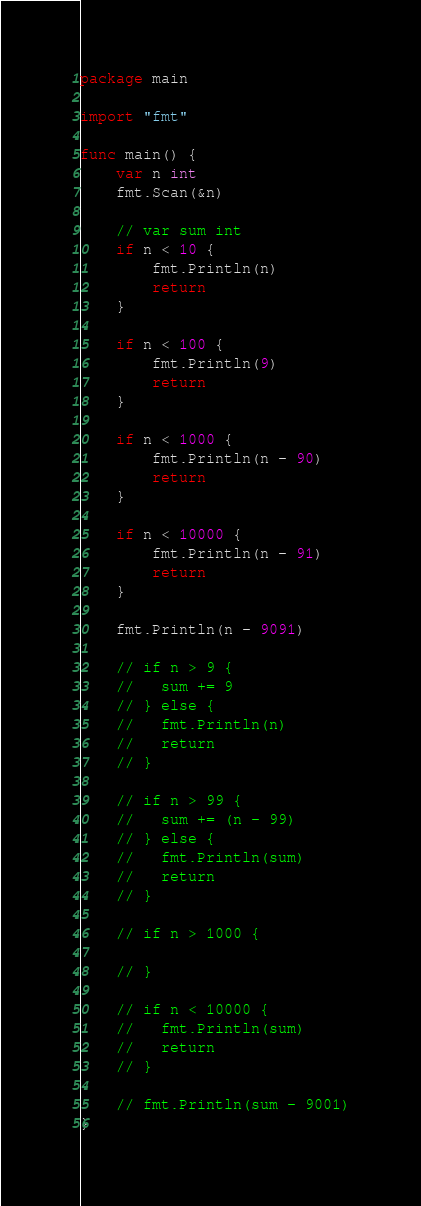Convert code to text. <code><loc_0><loc_0><loc_500><loc_500><_Go_>package main

import "fmt"

func main() {
	var n int
	fmt.Scan(&n)

	// var sum int
	if n < 10 {
		fmt.Println(n)
		return
	}

	if n < 100 {
		fmt.Println(9)
		return
	}

	if n < 1000 {
		fmt.Println(n - 90)
		return
	}

	if n < 10000 {
		fmt.Println(n - 91)
		return
	}

	fmt.Println(n - 9091)

	// if n > 9 {
	//   sum += 9
	// } else {
	//   fmt.Println(n)
	//   return
	// }

	// if n > 99 {
	//   sum += (n - 99)
	// } else {
	//   fmt.Println(sum)
	//   return
	// }

	// if n > 1000 {

	// }

	// if n < 10000 {
	//   fmt.Println(sum)
	//   return
	// }

	// fmt.Println(sum - 9001)
}
</code> 